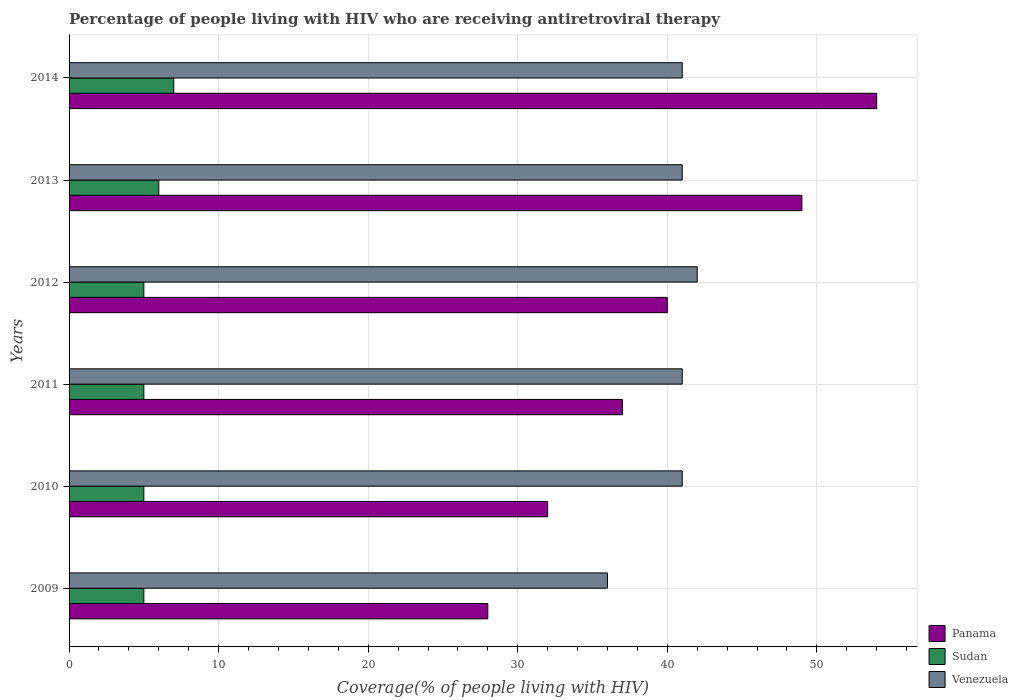Are the number of bars on each tick of the Y-axis equal?
Your answer should be compact. Yes. How many bars are there on the 5th tick from the top?
Offer a terse response. 3. How many bars are there on the 2nd tick from the bottom?
Give a very brief answer. 3. What is the percentage of the HIV infected people who are receiving antiretroviral therapy in Sudan in 2014?
Offer a very short reply. 7. Across all years, what is the maximum percentage of the HIV infected people who are receiving antiretroviral therapy in Panama?
Keep it short and to the point. 54. Across all years, what is the minimum percentage of the HIV infected people who are receiving antiretroviral therapy in Sudan?
Your answer should be compact. 5. In which year was the percentage of the HIV infected people who are receiving antiretroviral therapy in Panama maximum?
Offer a very short reply. 2014. What is the total percentage of the HIV infected people who are receiving antiretroviral therapy in Sudan in the graph?
Make the answer very short. 33. What is the difference between the percentage of the HIV infected people who are receiving antiretroviral therapy in Venezuela in 2012 and that in 2014?
Offer a very short reply. 1. What is the difference between the percentage of the HIV infected people who are receiving antiretroviral therapy in Sudan in 2010 and the percentage of the HIV infected people who are receiving antiretroviral therapy in Panama in 2014?
Make the answer very short. -49. What is the average percentage of the HIV infected people who are receiving antiretroviral therapy in Panama per year?
Offer a very short reply. 40. In the year 2009, what is the difference between the percentage of the HIV infected people who are receiving antiretroviral therapy in Sudan and percentage of the HIV infected people who are receiving antiretroviral therapy in Venezuela?
Offer a very short reply. -31. What is the ratio of the percentage of the HIV infected people who are receiving antiretroviral therapy in Sudan in 2009 to that in 2012?
Ensure brevity in your answer.  1. What is the difference between the highest and the lowest percentage of the HIV infected people who are receiving antiretroviral therapy in Panama?
Your answer should be very brief. 26. What does the 3rd bar from the top in 2012 represents?
Offer a very short reply. Panama. What does the 2nd bar from the bottom in 2009 represents?
Ensure brevity in your answer.  Sudan. How many bars are there?
Provide a succinct answer. 18. What is the difference between two consecutive major ticks on the X-axis?
Keep it short and to the point. 10. Does the graph contain grids?
Provide a succinct answer. Yes. Where does the legend appear in the graph?
Your answer should be compact. Bottom right. How are the legend labels stacked?
Your answer should be very brief. Vertical. What is the title of the graph?
Your response must be concise. Percentage of people living with HIV who are receiving antiretroviral therapy. What is the label or title of the X-axis?
Provide a short and direct response. Coverage(% of people living with HIV). What is the Coverage(% of people living with HIV) of Sudan in 2009?
Your answer should be very brief. 5. What is the Coverage(% of people living with HIV) of Venezuela in 2009?
Offer a terse response. 36. What is the Coverage(% of people living with HIV) of Panama in 2010?
Your response must be concise. 32. What is the Coverage(% of people living with HIV) in Sudan in 2010?
Your answer should be very brief. 5. What is the Coverage(% of people living with HIV) in Venezuela in 2011?
Your answer should be very brief. 41. What is the Coverage(% of people living with HIV) of Sudan in 2012?
Give a very brief answer. 5. What is the Coverage(% of people living with HIV) in Venezuela in 2012?
Provide a short and direct response. 42. What is the Coverage(% of people living with HIV) of Panama in 2013?
Give a very brief answer. 49. What is the Coverage(% of people living with HIV) in Sudan in 2013?
Give a very brief answer. 6. What is the Coverage(% of people living with HIV) in Panama in 2014?
Offer a terse response. 54. What is the Coverage(% of people living with HIV) of Sudan in 2014?
Your response must be concise. 7. What is the Coverage(% of people living with HIV) in Venezuela in 2014?
Ensure brevity in your answer.  41. Across all years, what is the maximum Coverage(% of people living with HIV) in Sudan?
Provide a short and direct response. 7. Across all years, what is the minimum Coverage(% of people living with HIV) of Panama?
Provide a succinct answer. 28. What is the total Coverage(% of people living with HIV) in Panama in the graph?
Your answer should be very brief. 240. What is the total Coverage(% of people living with HIV) of Sudan in the graph?
Offer a very short reply. 33. What is the total Coverage(% of people living with HIV) in Venezuela in the graph?
Make the answer very short. 242. What is the difference between the Coverage(% of people living with HIV) of Venezuela in 2009 and that in 2010?
Keep it short and to the point. -5. What is the difference between the Coverage(% of people living with HIV) of Panama in 2009 and that in 2011?
Make the answer very short. -9. What is the difference between the Coverage(% of people living with HIV) of Sudan in 2009 and that in 2011?
Offer a terse response. 0. What is the difference between the Coverage(% of people living with HIV) in Venezuela in 2009 and that in 2011?
Make the answer very short. -5. What is the difference between the Coverage(% of people living with HIV) of Panama in 2009 and that in 2012?
Provide a succinct answer. -12. What is the difference between the Coverage(% of people living with HIV) in Sudan in 2009 and that in 2012?
Ensure brevity in your answer.  0. What is the difference between the Coverage(% of people living with HIV) of Venezuela in 2009 and that in 2012?
Offer a terse response. -6. What is the difference between the Coverage(% of people living with HIV) of Panama in 2009 and that in 2013?
Ensure brevity in your answer.  -21. What is the difference between the Coverage(% of people living with HIV) of Sudan in 2009 and that in 2013?
Your answer should be compact. -1. What is the difference between the Coverage(% of people living with HIV) in Venezuela in 2009 and that in 2013?
Ensure brevity in your answer.  -5. What is the difference between the Coverage(% of people living with HIV) in Panama in 2009 and that in 2014?
Provide a short and direct response. -26. What is the difference between the Coverage(% of people living with HIV) of Sudan in 2009 and that in 2014?
Your answer should be very brief. -2. What is the difference between the Coverage(% of people living with HIV) in Venezuela in 2009 and that in 2014?
Make the answer very short. -5. What is the difference between the Coverage(% of people living with HIV) in Panama in 2010 and that in 2011?
Ensure brevity in your answer.  -5. What is the difference between the Coverage(% of people living with HIV) of Sudan in 2010 and that in 2011?
Provide a succinct answer. 0. What is the difference between the Coverage(% of people living with HIV) in Venezuela in 2010 and that in 2011?
Your response must be concise. 0. What is the difference between the Coverage(% of people living with HIV) in Panama in 2010 and that in 2012?
Offer a terse response. -8. What is the difference between the Coverage(% of people living with HIV) of Venezuela in 2010 and that in 2012?
Keep it short and to the point. -1. What is the difference between the Coverage(% of people living with HIV) in Sudan in 2010 and that in 2013?
Ensure brevity in your answer.  -1. What is the difference between the Coverage(% of people living with HIV) of Sudan in 2010 and that in 2014?
Make the answer very short. -2. What is the difference between the Coverage(% of people living with HIV) in Panama in 2011 and that in 2012?
Keep it short and to the point. -3. What is the difference between the Coverage(% of people living with HIV) of Venezuela in 2011 and that in 2012?
Offer a very short reply. -1. What is the difference between the Coverage(% of people living with HIV) of Sudan in 2011 and that in 2013?
Provide a short and direct response. -1. What is the difference between the Coverage(% of people living with HIV) of Venezuela in 2011 and that in 2013?
Keep it short and to the point. 0. What is the difference between the Coverage(% of people living with HIV) in Panama in 2011 and that in 2014?
Keep it short and to the point. -17. What is the difference between the Coverage(% of people living with HIV) of Venezuela in 2011 and that in 2014?
Make the answer very short. 0. What is the difference between the Coverage(% of people living with HIV) in Panama in 2012 and that in 2013?
Your answer should be very brief. -9. What is the difference between the Coverage(% of people living with HIV) of Panama in 2012 and that in 2014?
Your answer should be very brief. -14. What is the difference between the Coverage(% of people living with HIV) of Panama in 2013 and that in 2014?
Ensure brevity in your answer.  -5. What is the difference between the Coverage(% of people living with HIV) in Venezuela in 2013 and that in 2014?
Ensure brevity in your answer.  0. What is the difference between the Coverage(% of people living with HIV) in Sudan in 2009 and the Coverage(% of people living with HIV) in Venezuela in 2010?
Ensure brevity in your answer.  -36. What is the difference between the Coverage(% of people living with HIV) of Panama in 2009 and the Coverage(% of people living with HIV) of Sudan in 2011?
Offer a terse response. 23. What is the difference between the Coverage(% of people living with HIV) in Sudan in 2009 and the Coverage(% of people living with HIV) in Venezuela in 2011?
Offer a very short reply. -36. What is the difference between the Coverage(% of people living with HIV) in Sudan in 2009 and the Coverage(% of people living with HIV) in Venezuela in 2012?
Give a very brief answer. -37. What is the difference between the Coverage(% of people living with HIV) in Panama in 2009 and the Coverage(% of people living with HIV) in Sudan in 2013?
Give a very brief answer. 22. What is the difference between the Coverage(% of people living with HIV) in Panama in 2009 and the Coverage(% of people living with HIV) in Venezuela in 2013?
Provide a succinct answer. -13. What is the difference between the Coverage(% of people living with HIV) of Sudan in 2009 and the Coverage(% of people living with HIV) of Venezuela in 2013?
Your answer should be compact. -36. What is the difference between the Coverage(% of people living with HIV) in Panama in 2009 and the Coverage(% of people living with HIV) in Venezuela in 2014?
Your answer should be very brief. -13. What is the difference between the Coverage(% of people living with HIV) of Sudan in 2009 and the Coverage(% of people living with HIV) of Venezuela in 2014?
Your answer should be very brief. -36. What is the difference between the Coverage(% of people living with HIV) of Sudan in 2010 and the Coverage(% of people living with HIV) of Venezuela in 2011?
Your response must be concise. -36. What is the difference between the Coverage(% of people living with HIV) in Panama in 2010 and the Coverage(% of people living with HIV) in Sudan in 2012?
Provide a short and direct response. 27. What is the difference between the Coverage(% of people living with HIV) in Sudan in 2010 and the Coverage(% of people living with HIV) in Venezuela in 2012?
Keep it short and to the point. -37. What is the difference between the Coverage(% of people living with HIV) in Sudan in 2010 and the Coverage(% of people living with HIV) in Venezuela in 2013?
Give a very brief answer. -36. What is the difference between the Coverage(% of people living with HIV) of Panama in 2010 and the Coverage(% of people living with HIV) of Sudan in 2014?
Keep it short and to the point. 25. What is the difference between the Coverage(% of people living with HIV) in Sudan in 2010 and the Coverage(% of people living with HIV) in Venezuela in 2014?
Ensure brevity in your answer.  -36. What is the difference between the Coverage(% of people living with HIV) in Panama in 2011 and the Coverage(% of people living with HIV) in Sudan in 2012?
Ensure brevity in your answer.  32. What is the difference between the Coverage(% of people living with HIV) of Panama in 2011 and the Coverage(% of people living with HIV) of Venezuela in 2012?
Ensure brevity in your answer.  -5. What is the difference between the Coverage(% of people living with HIV) in Sudan in 2011 and the Coverage(% of people living with HIV) in Venezuela in 2012?
Offer a terse response. -37. What is the difference between the Coverage(% of people living with HIV) of Panama in 2011 and the Coverage(% of people living with HIV) of Sudan in 2013?
Offer a very short reply. 31. What is the difference between the Coverage(% of people living with HIV) of Sudan in 2011 and the Coverage(% of people living with HIV) of Venezuela in 2013?
Keep it short and to the point. -36. What is the difference between the Coverage(% of people living with HIV) in Panama in 2011 and the Coverage(% of people living with HIV) in Sudan in 2014?
Give a very brief answer. 30. What is the difference between the Coverage(% of people living with HIV) of Sudan in 2011 and the Coverage(% of people living with HIV) of Venezuela in 2014?
Your answer should be very brief. -36. What is the difference between the Coverage(% of people living with HIV) in Panama in 2012 and the Coverage(% of people living with HIV) in Sudan in 2013?
Your answer should be compact. 34. What is the difference between the Coverage(% of people living with HIV) in Panama in 2012 and the Coverage(% of people living with HIV) in Venezuela in 2013?
Offer a very short reply. -1. What is the difference between the Coverage(% of people living with HIV) of Sudan in 2012 and the Coverage(% of people living with HIV) of Venezuela in 2013?
Keep it short and to the point. -36. What is the difference between the Coverage(% of people living with HIV) in Panama in 2012 and the Coverage(% of people living with HIV) in Venezuela in 2014?
Give a very brief answer. -1. What is the difference between the Coverage(% of people living with HIV) in Sudan in 2012 and the Coverage(% of people living with HIV) in Venezuela in 2014?
Offer a terse response. -36. What is the difference between the Coverage(% of people living with HIV) of Panama in 2013 and the Coverage(% of people living with HIV) of Venezuela in 2014?
Your response must be concise. 8. What is the difference between the Coverage(% of people living with HIV) in Sudan in 2013 and the Coverage(% of people living with HIV) in Venezuela in 2014?
Provide a short and direct response. -35. What is the average Coverage(% of people living with HIV) of Panama per year?
Ensure brevity in your answer.  40. What is the average Coverage(% of people living with HIV) of Sudan per year?
Make the answer very short. 5.5. What is the average Coverage(% of people living with HIV) of Venezuela per year?
Your answer should be compact. 40.33. In the year 2009, what is the difference between the Coverage(% of people living with HIV) of Sudan and Coverage(% of people living with HIV) of Venezuela?
Keep it short and to the point. -31. In the year 2010, what is the difference between the Coverage(% of people living with HIV) of Panama and Coverage(% of people living with HIV) of Venezuela?
Your response must be concise. -9. In the year 2010, what is the difference between the Coverage(% of people living with HIV) in Sudan and Coverage(% of people living with HIV) in Venezuela?
Your answer should be compact. -36. In the year 2011, what is the difference between the Coverage(% of people living with HIV) in Panama and Coverage(% of people living with HIV) in Sudan?
Offer a terse response. 32. In the year 2011, what is the difference between the Coverage(% of people living with HIV) in Panama and Coverage(% of people living with HIV) in Venezuela?
Keep it short and to the point. -4. In the year 2011, what is the difference between the Coverage(% of people living with HIV) of Sudan and Coverage(% of people living with HIV) of Venezuela?
Make the answer very short. -36. In the year 2012, what is the difference between the Coverage(% of people living with HIV) in Panama and Coverage(% of people living with HIV) in Venezuela?
Give a very brief answer. -2. In the year 2012, what is the difference between the Coverage(% of people living with HIV) of Sudan and Coverage(% of people living with HIV) of Venezuela?
Your answer should be very brief. -37. In the year 2013, what is the difference between the Coverage(% of people living with HIV) in Sudan and Coverage(% of people living with HIV) in Venezuela?
Offer a very short reply. -35. In the year 2014, what is the difference between the Coverage(% of people living with HIV) in Panama and Coverage(% of people living with HIV) in Venezuela?
Keep it short and to the point. 13. In the year 2014, what is the difference between the Coverage(% of people living with HIV) of Sudan and Coverage(% of people living with HIV) of Venezuela?
Your response must be concise. -34. What is the ratio of the Coverage(% of people living with HIV) of Sudan in 2009 to that in 2010?
Provide a short and direct response. 1. What is the ratio of the Coverage(% of people living with HIV) of Venezuela in 2009 to that in 2010?
Provide a succinct answer. 0.88. What is the ratio of the Coverage(% of people living with HIV) in Panama in 2009 to that in 2011?
Make the answer very short. 0.76. What is the ratio of the Coverage(% of people living with HIV) of Venezuela in 2009 to that in 2011?
Provide a short and direct response. 0.88. What is the ratio of the Coverage(% of people living with HIV) in Venezuela in 2009 to that in 2012?
Provide a short and direct response. 0.86. What is the ratio of the Coverage(% of people living with HIV) in Sudan in 2009 to that in 2013?
Provide a succinct answer. 0.83. What is the ratio of the Coverage(% of people living with HIV) of Venezuela in 2009 to that in 2013?
Provide a succinct answer. 0.88. What is the ratio of the Coverage(% of people living with HIV) of Panama in 2009 to that in 2014?
Provide a succinct answer. 0.52. What is the ratio of the Coverage(% of people living with HIV) in Sudan in 2009 to that in 2014?
Provide a short and direct response. 0.71. What is the ratio of the Coverage(% of people living with HIV) of Venezuela in 2009 to that in 2014?
Ensure brevity in your answer.  0.88. What is the ratio of the Coverage(% of people living with HIV) of Panama in 2010 to that in 2011?
Provide a short and direct response. 0.86. What is the ratio of the Coverage(% of people living with HIV) of Sudan in 2010 to that in 2011?
Provide a succinct answer. 1. What is the ratio of the Coverage(% of people living with HIV) of Venezuela in 2010 to that in 2011?
Offer a very short reply. 1. What is the ratio of the Coverage(% of people living with HIV) of Panama in 2010 to that in 2012?
Make the answer very short. 0.8. What is the ratio of the Coverage(% of people living with HIV) in Sudan in 2010 to that in 2012?
Provide a short and direct response. 1. What is the ratio of the Coverage(% of people living with HIV) of Venezuela in 2010 to that in 2012?
Offer a very short reply. 0.98. What is the ratio of the Coverage(% of people living with HIV) in Panama in 2010 to that in 2013?
Make the answer very short. 0.65. What is the ratio of the Coverage(% of people living with HIV) in Panama in 2010 to that in 2014?
Provide a succinct answer. 0.59. What is the ratio of the Coverage(% of people living with HIV) in Panama in 2011 to that in 2012?
Provide a succinct answer. 0.93. What is the ratio of the Coverage(% of people living with HIV) in Sudan in 2011 to that in 2012?
Make the answer very short. 1. What is the ratio of the Coverage(% of people living with HIV) of Venezuela in 2011 to that in 2012?
Offer a terse response. 0.98. What is the ratio of the Coverage(% of people living with HIV) of Panama in 2011 to that in 2013?
Offer a very short reply. 0.76. What is the ratio of the Coverage(% of people living with HIV) of Venezuela in 2011 to that in 2013?
Offer a terse response. 1. What is the ratio of the Coverage(% of people living with HIV) in Panama in 2011 to that in 2014?
Your response must be concise. 0.69. What is the ratio of the Coverage(% of people living with HIV) of Sudan in 2011 to that in 2014?
Your answer should be compact. 0.71. What is the ratio of the Coverage(% of people living with HIV) of Venezuela in 2011 to that in 2014?
Provide a succinct answer. 1. What is the ratio of the Coverage(% of people living with HIV) in Panama in 2012 to that in 2013?
Offer a terse response. 0.82. What is the ratio of the Coverage(% of people living with HIV) in Sudan in 2012 to that in 2013?
Offer a terse response. 0.83. What is the ratio of the Coverage(% of people living with HIV) in Venezuela in 2012 to that in 2013?
Provide a short and direct response. 1.02. What is the ratio of the Coverage(% of people living with HIV) in Panama in 2012 to that in 2014?
Your response must be concise. 0.74. What is the ratio of the Coverage(% of people living with HIV) in Venezuela in 2012 to that in 2014?
Provide a short and direct response. 1.02. What is the ratio of the Coverage(% of people living with HIV) of Panama in 2013 to that in 2014?
Ensure brevity in your answer.  0.91. What is the ratio of the Coverage(% of people living with HIV) in Sudan in 2013 to that in 2014?
Offer a terse response. 0.86. What is the difference between the highest and the lowest Coverage(% of people living with HIV) of Panama?
Make the answer very short. 26. What is the difference between the highest and the lowest Coverage(% of people living with HIV) of Venezuela?
Keep it short and to the point. 6. 